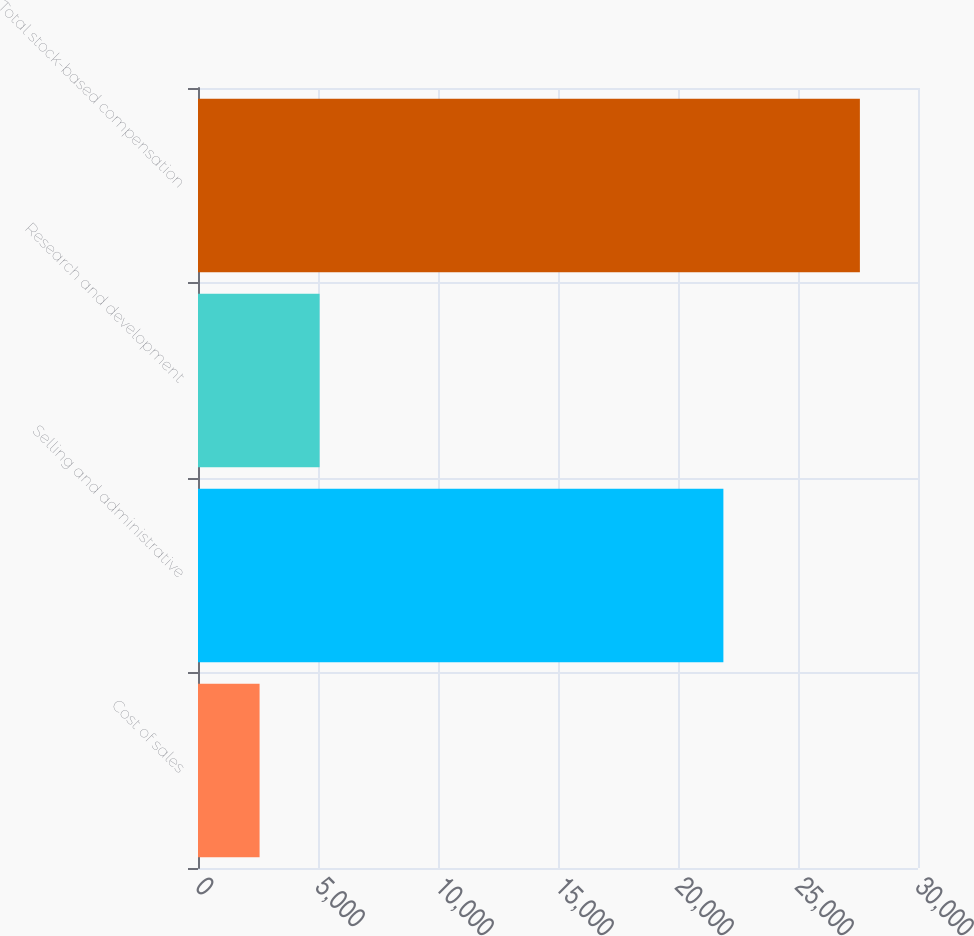<chart> <loc_0><loc_0><loc_500><loc_500><bar_chart><fcel>Cost of sales<fcel>Selling and administrative<fcel>Research and development<fcel>Total stock-based compensation<nl><fcel>2566<fcel>21891<fcel>5067.3<fcel>27579<nl></chart> 